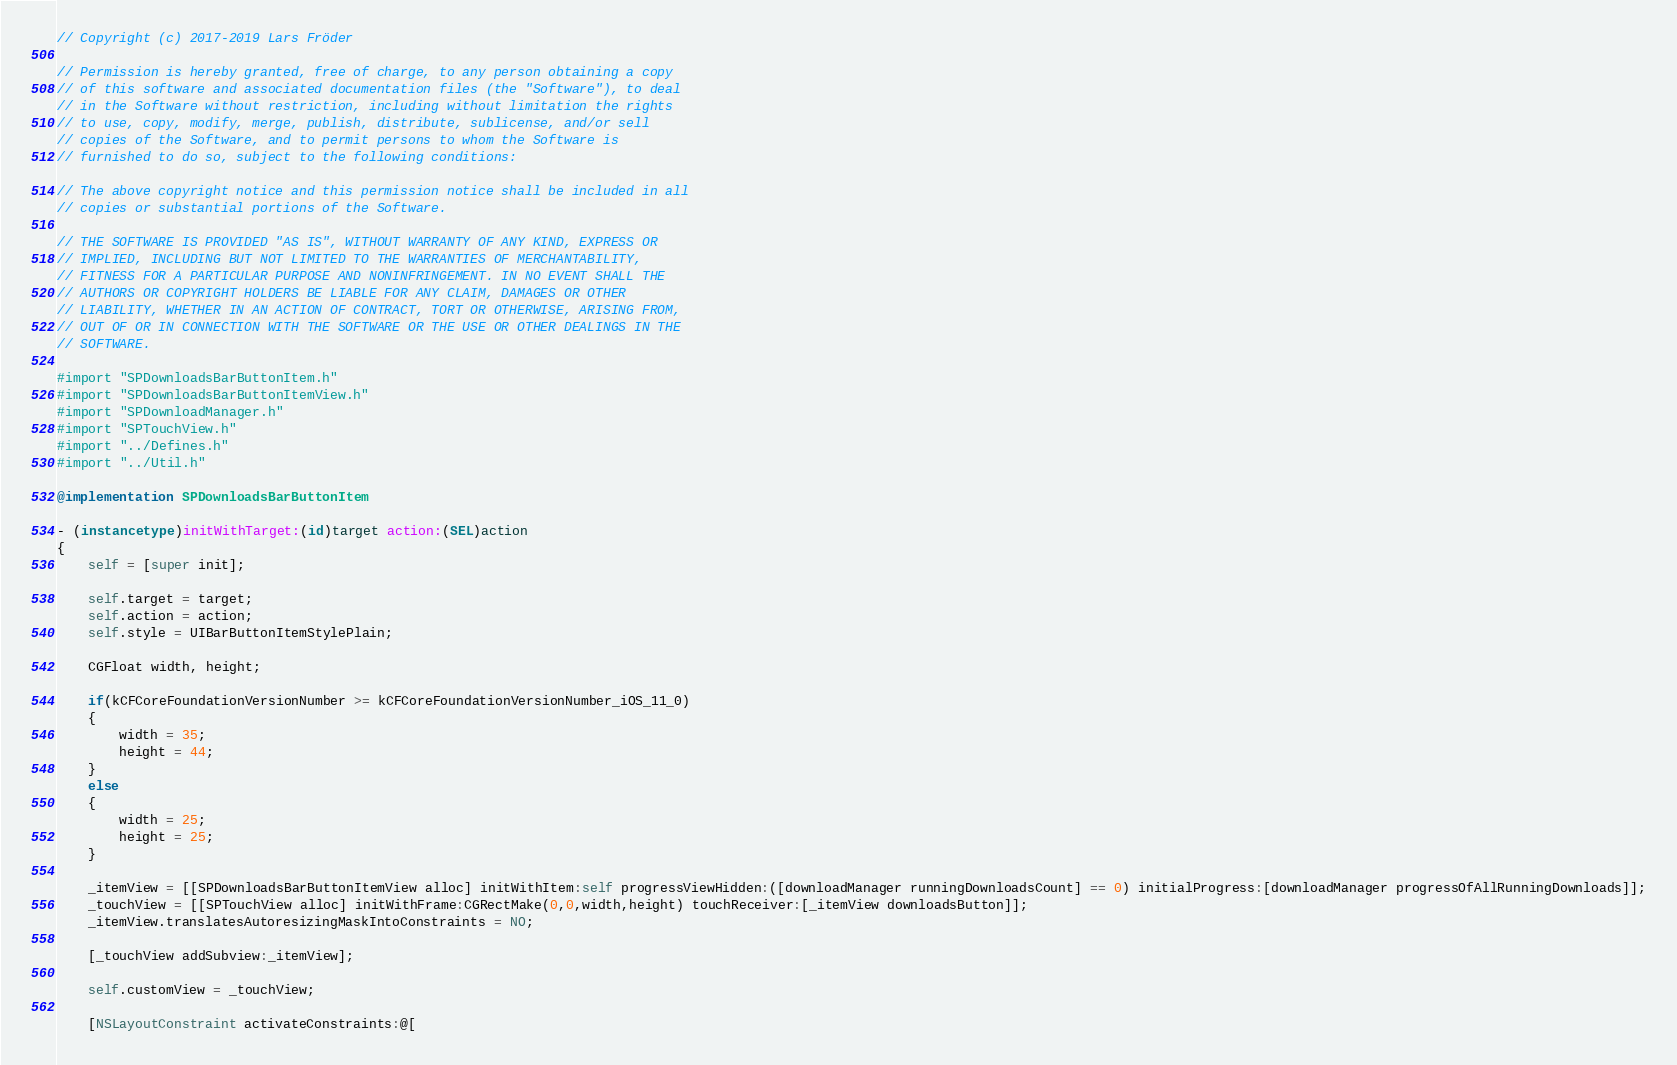<code> <loc_0><loc_0><loc_500><loc_500><_ObjectiveC_>// Copyright (c) 2017-2019 Lars Fröder

// Permission is hereby granted, free of charge, to any person obtaining a copy
// of this software and associated documentation files (the "Software"), to deal
// in the Software without restriction, including without limitation the rights
// to use, copy, modify, merge, publish, distribute, sublicense, and/or sell
// copies of the Software, and to permit persons to whom the Software is
// furnished to do so, subject to the following conditions:

// The above copyright notice and this permission notice shall be included in all
// copies or substantial portions of the Software.

// THE SOFTWARE IS PROVIDED "AS IS", WITHOUT WARRANTY OF ANY KIND, EXPRESS OR
// IMPLIED, INCLUDING BUT NOT LIMITED TO THE WARRANTIES OF MERCHANTABILITY,
// FITNESS FOR A PARTICULAR PURPOSE AND NONINFRINGEMENT. IN NO EVENT SHALL THE
// AUTHORS OR COPYRIGHT HOLDERS BE LIABLE FOR ANY CLAIM, DAMAGES OR OTHER
// LIABILITY, WHETHER IN AN ACTION OF CONTRACT, TORT OR OTHERWISE, ARISING FROM,
// OUT OF OR IN CONNECTION WITH THE SOFTWARE OR THE USE OR OTHER DEALINGS IN THE
// SOFTWARE.

#import "SPDownloadsBarButtonItem.h"
#import "SPDownloadsBarButtonItemView.h"
#import "SPDownloadManager.h"
#import "SPTouchView.h"
#import "../Defines.h"
#import "../Util.h"

@implementation SPDownloadsBarButtonItem

- (instancetype)initWithTarget:(id)target action:(SEL)action
{
	self = [super init];

	self.target = target;
	self.action = action;
	self.style = UIBarButtonItemStylePlain;

	CGFloat width, height;

	if(kCFCoreFoundationVersionNumber >= kCFCoreFoundationVersionNumber_iOS_11_0)
	{
		width = 35;
		height = 44;
	}
	else
	{
		width = 25;
		height = 25;
	}

	_itemView = [[SPDownloadsBarButtonItemView alloc] initWithItem:self progressViewHidden:([downloadManager runningDownloadsCount] == 0) initialProgress:[downloadManager progressOfAllRunningDownloads]];
	_touchView = [[SPTouchView alloc] initWithFrame:CGRectMake(0,0,width,height) touchReceiver:[_itemView downloadsButton]];
	_itemView.translatesAutoresizingMaskIntoConstraints = NO;

	[_touchView addSubview:_itemView];

	self.customView = _touchView;

	[NSLayoutConstraint activateConstraints:@[</code> 